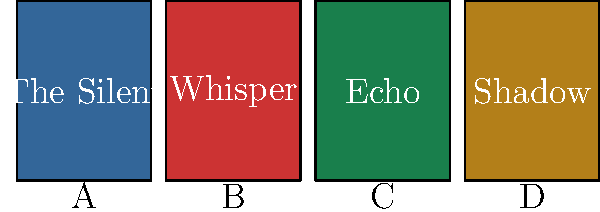Based on the book cover designs shown above, which series of mystery novels is most likely represented by these titles, considering the color scheme and one-word titles? To identify the mystery novel series, we need to analyze the visual elements and titles:

1. Color scheme: The covers use distinct, bold colors (dark blue, red, green, and yellow-brown), which is typical for mystery or thriller series to create a sense of intrigue.

2. Title format: Each book has a single-word title, which is a common approach for creating a cohesive series.

3. Title meanings:
   - "The Silent" suggests secrecy or something unspoken.
   - "Whisper" implies quiet communication or secrets.
   - "Echo" can represent repetition or lingering effects of past events.
   - "Shadow" often symbolizes mystery or hidden elements.

4. Series connection: The titles seem to be thematically linked, all relating to concepts of silence, subtlety, or hidden things.

5. Mystery genre fit: The combination of bold colors and evocative, single-word titles strongly suggests a mystery or thriller series.

Given these elements, the most likely answer is that this represents "The Stillhouse Lake" series by Rachel Caine. This popular mystery series features similar design elements and single-word titles related to silence and hidden dangers.
Answer: The Stillhouse Lake series 